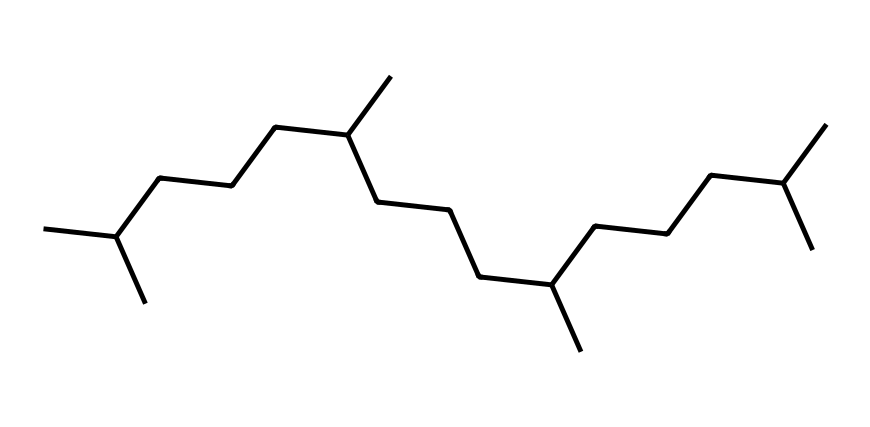1. What is the carbon count in this chemical structure? By analyzing the SMILES representation, we can count the carbon atoms by identifying every carbon (C) present in the chain. The structure shows a long carbon chain with branching. Counting manually reveals there are 21 carbon atoms total.
Answer: 21 2. How many hydrogen atoms are likely bonded to this hydrocarbon? Each carbon can form four bonds. In a fully saturated alkane, the general formula is CnH2n+2. Here, with 21 carbon atoms (n=21), we calculate the hydrogen atoms using the formula: 2(21)+2 = 44.
Answer: 44 3. What type of hydrocarbon is this lubricant likely to be? The structure shows only carbon and hydrogen atoms with single bonds and long chains, indicating it is a saturated hydrocarbon, specifically an alkane.
Answer: alkane 4. Which structural feature contributes to its viscosity? The long carbon chain contributes to the lubricant's viscosity due to its increased molecular weight and chain length. Longer chains typically lead to higher resistance to flow, hence increased viscosity.
Answer: long carbon chain 5. What is the main purpose of this chemical in cooling systems for data centers? This synthetic hydrocarbon lubricant primarily serves as a coolant, providing a medium that reduces friction and dissipates heat within the cooling systems, enhancing efficiency.
Answer: coolant 6. Why are synthetic hydrocarbons preferred over traditional oils in cooling systems? Synthetic hydrocarbons are often chosen because they offer better thermal stability, lower volatility, and a more tailored viscosity range, which gives them superior performance in varying temperatures.
Answer: thermal stability 7. How does branching in this molecule affect its properties? Branching in alkane hydrocarbons generally results in lower boiling points and reduced viscosity compared to straight-chain isomers, making branched lubricants more efficient and effective in certain cooling applications.
Answer: lower viscosity 